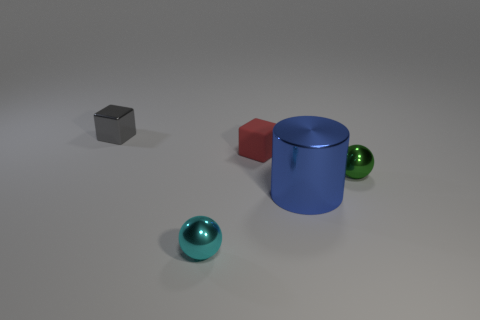There is a small shiny thing behind the small green shiny thing; is its shape the same as the blue thing?
Ensure brevity in your answer.  No. How many things are objects in front of the tiny shiny block or tiny metallic balls that are to the left of the green metal ball?
Your answer should be compact. 4. The other object that is the same shape as the cyan shiny thing is what color?
Provide a succinct answer. Green. Is there any other thing that has the same shape as the big shiny thing?
Your response must be concise. No. Does the tiny cyan thing have the same shape as the small metal object to the right of the rubber cube?
Ensure brevity in your answer.  Yes. What material is the red block?
Offer a very short reply. Rubber. There is another object that is the same shape as the small red matte object; what size is it?
Give a very brief answer. Small. How many other things are there of the same material as the tiny red object?
Provide a short and direct response. 0. Are the cylinder and the tiny block that is in front of the gray metal block made of the same material?
Make the answer very short. No. Is the number of matte blocks that are on the right side of the tiny gray metal cube less than the number of small balls in front of the red rubber block?
Offer a terse response. Yes. 